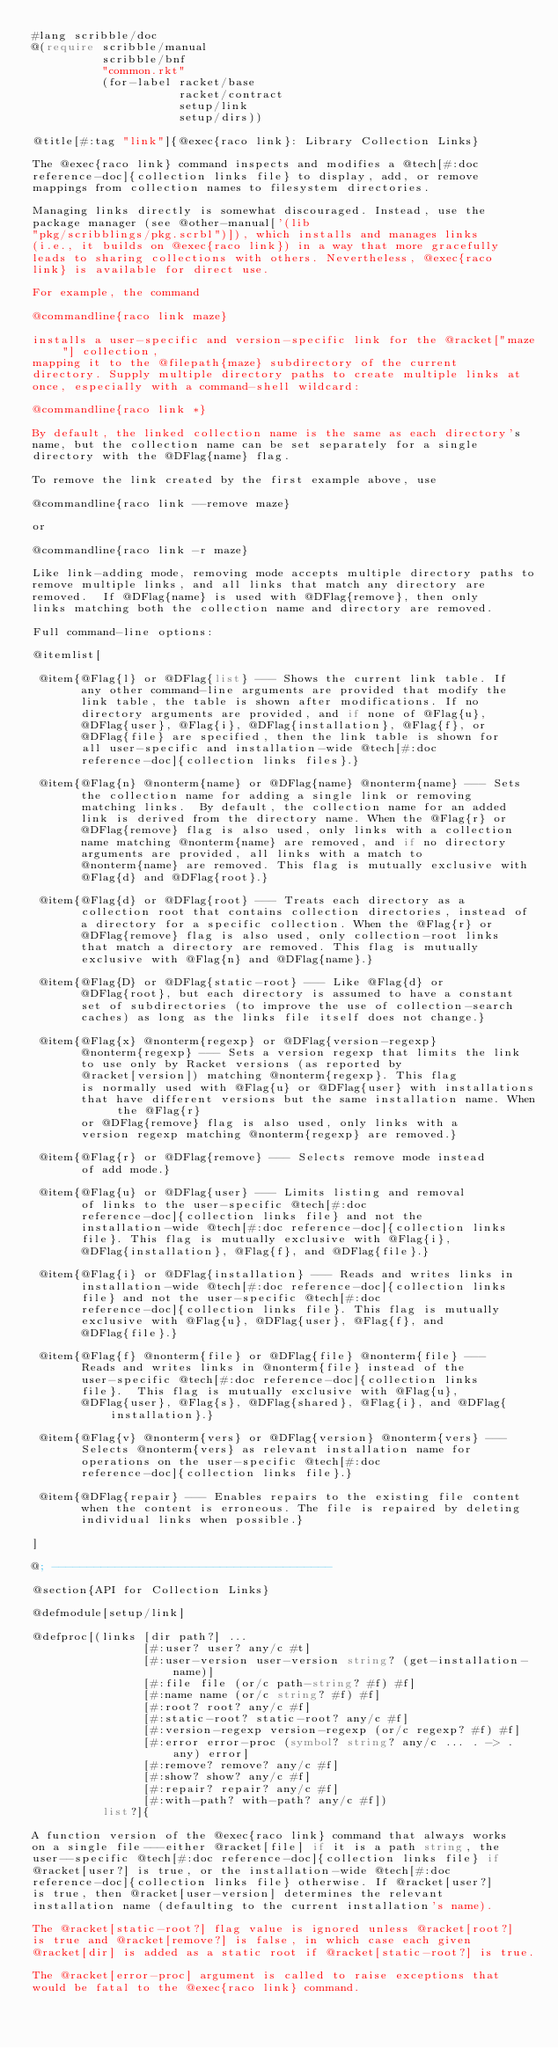Convert code to text. <code><loc_0><loc_0><loc_500><loc_500><_Racket_>#lang scribble/doc
@(require scribble/manual
          scribble/bnf 
          "common.rkt"
          (for-label racket/base
                     racket/contract
                     setup/link
                     setup/dirs))

@title[#:tag "link"]{@exec{raco link}: Library Collection Links}

The @exec{raco link} command inspects and modifies a @tech[#:doc
reference-doc]{collection links file} to display, add, or remove
mappings from collection names to filesystem directories.

Managing links directly is somewhat discouraged. Instead, use the
package manager (see @other-manual['(lib
"pkg/scribblings/pkg.scrbl")]), which installs and manages links
(i.e., it builds on @exec{raco link}) in a way that more gracefully
leads to sharing collections with others. Nevertheless, @exec{raco
link} is available for direct use.

For example, the command

@commandline{raco link maze}

installs a user-specific and version-specific link for the @racket["maze"] collection,
mapping it to the @filepath{maze} subdirectory of the current
directory. Supply multiple directory paths to create multiple links at
once, especially with a command-shell wildcard:

@commandline{raco link *}

By default, the linked collection name is the same as each directory's
name, but the collection name can be set separately for a single
directory with the @DFlag{name} flag.

To remove the link created by the first example above, use

@commandline{raco link --remove maze}

or 

@commandline{raco link -r maze}

Like link-adding mode, removing mode accepts multiple directory paths to
remove multiple links, and all links that match any directory are
removed.  If @DFlag{name} is used with @DFlag{remove}, then only
links matching both the collection name and directory are removed.

Full command-line options:

@itemlist[

 @item{@Flag{l} or @DFlag{list} --- Shows the current link table. If
       any other command-line arguments are provided that modify the
       link table, the table is shown after modifications. If no
       directory arguments are provided, and if none of @Flag{u},
       @DFlag{user}, @Flag{i}, @DFlag{installation}, @Flag{f}, or
       @DFlag{file} are specified, then the link table is shown for
       all user-specific and installation-wide @tech[#:doc
       reference-doc]{collection links files}.}

 @item{@Flag{n} @nonterm{name} or @DFlag{name} @nonterm{name} --- Sets
       the collection name for adding a single link or removing
       matching links.  By default, the collection name for an added
       link is derived from the directory name. When the @Flag{r} or
       @DFlag{remove} flag is also used, only links with a collection
       name matching @nonterm{name} are removed, and if no directory
       arguments are provided, all links with a match to
       @nonterm{name} are removed. This flag is mutually exclusive with
       @Flag{d} and @DFlag{root}.}

 @item{@Flag{d} or @DFlag{root} --- Treats each directory as a
       collection root that contains collection directories, instead of
       a directory for a specific collection. When the @Flag{r} or
       @DFlag{remove} flag is also used, only collection-root links
       that match a directory are removed. This flag is mutually
       exclusive with @Flag{n} and @DFlag{name}.}

 @item{@Flag{D} or @DFlag{static-root} --- Like @Flag{d} or
       @DFlag{root}, but each directory is assumed to have a constant
       set of subdirectories (to improve the use of collection-search
       caches) as long as the links file itself does not change.}

 @item{@Flag{x} @nonterm{regexp} or @DFlag{version-regexp}
       @nonterm{regexp} --- Sets a version regexp that limits the link
       to use only by Racket versions (as reported by
       @racket[version]) matching @nonterm{regexp}. This flag
       is normally used with @Flag{u} or @DFlag{user} with installations
       that have different versions but the same installation name. When the @Flag{r}
       or @DFlag{remove} flag is also used, only links with a
       version regexp matching @nonterm{regexp} are removed.}

 @item{@Flag{r} or @DFlag{remove} --- Selects remove mode instead
       of add mode.}

 @item{@Flag{u} or @DFlag{user} --- Limits listing and removal
       of links to the user-specific @tech[#:doc
       reference-doc]{collection links file} and not the
       installation-wide @tech[#:doc reference-doc]{collection links
       file}. This flag is mutually exclusive with @Flag{i},
       @DFlag{installation}, @Flag{f}, and @DFlag{file}.}

 @item{@Flag{i} or @DFlag{installation} --- Reads and writes links in
       installation-wide @tech[#:doc reference-doc]{collection links
       file} and not the user-specific @tech[#:doc
       reference-doc]{collection links file}. This flag is mutually
       exclusive with @Flag{u}, @DFlag{user}, @Flag{f}, and
       @DFlag{file}.}

 @item{@Flag{f} @nonterm{file} or @DFlag{file} @nonterm{file} ---
       Reads and writes links in @nonterm{file} instead of the
       user-specific @tech[#:doc reference-doc]{collection links
       file}.  This flag is mutually exclusive with @Flag{u},
       @DFlag{user}, @Flag{s}, @DFlag{shared}, @Flag{i}, and @DFlag{installation}.}

 @item{@Flag{v} @nonterm{vers} or @DFlag{version} @nonterm{vers} ---
       Selects @nonterm{vers} as relevant installation name for
       operations on the user-specific @tech[#:doc
       reference-doc]{collection links file}.}

 @item{@DFlag{repair} --- Enables repairs to the existing file content
       when the content is erroneous. The file is repaired by deleting
       individual links when possible.}

]

@; ----------------------------------------

@section{API for Collection Links}

@defmodule[setup/link]

@defproc[(links [dir path?] ...
                [#:user? user? any/c #t]
                [#:user-version user-version string? (get-installation-name)]
                [#:file file (or/c path-string? #f) #f]
                [#:name name (or/c string? #f) #f]
                [#:root? root? any/c #f]
                [#:static-root? static-root? any/c #f]
                [#:version-regexp version-regexp (or/c regexp? #f) #f]
                [#:error error-proc (symbol? string? any/c ... . -> . any) error]
                [#:remove? remove? any/c #f]
                [#:show? show? any/c #f]
                [#:repair? repair? any/c #f]
                [#:with-path? with-path? any/c #f])
          list?]{

A function version of the @exec{raco link} command that always works
on a single file---either @racket[file] if it is a path string, the
user--specific @tech[#:doc reference-doc]{collection links file} if
@racket[user?] is true, or the installation-wide @tech[#:doc
reference-doc]{collection links file} otherwise. If @racket[user?]
is true, then @racket[user-version] determines the relevant
installation name (defaulting to the current installation's name).

The @racket[static-root?] flag value is ignored unless @racket[root?]
is true and @racket[remove?] is false, in which case each given
@racket[dir] is added as a static root if @racket[static-root?] is true.

The @racket[error-proc] argument is called to raise exceptions that
would be fatal to the @exec{raco link} command.
</code> 